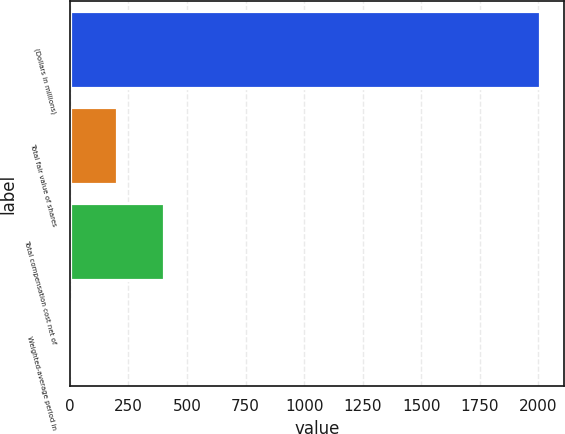Convert chart. <chart><loc_0><loc_0><loc_500><loc_500><bar_chart><fcel>(Dollars in millions)<fcel>Total fair value of shares<fcel>Total compensation cost net of<fcel>Weighted-average period in<nl><fcel>2008<fcel>201.7<fcel>402.4<fcel>1<nl></chart> 